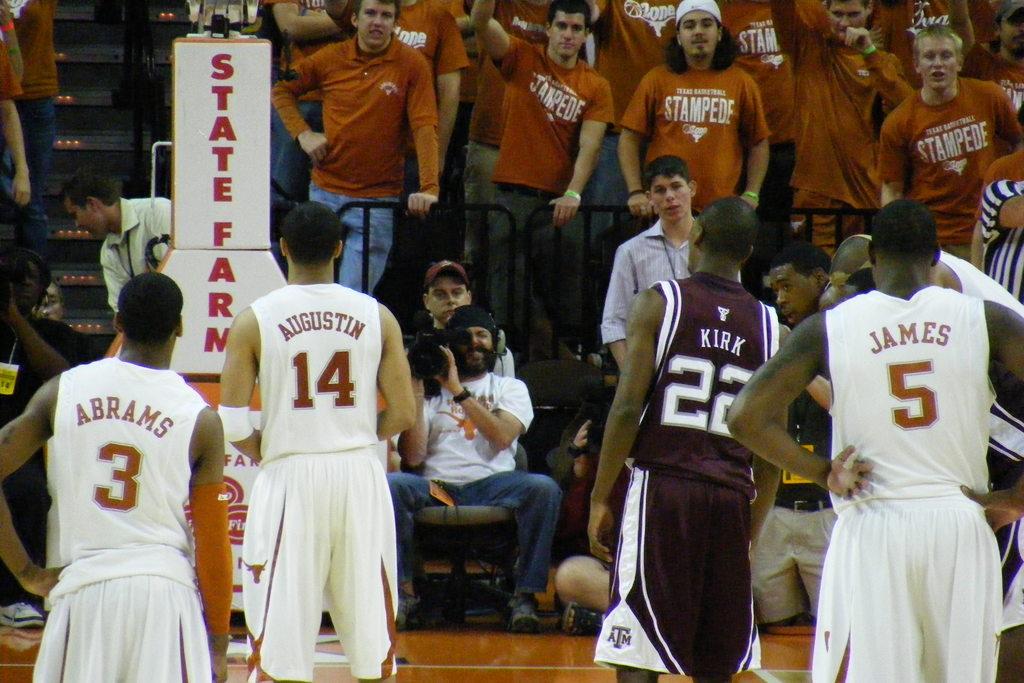What is james' number?
Your response must be concise. 5. 